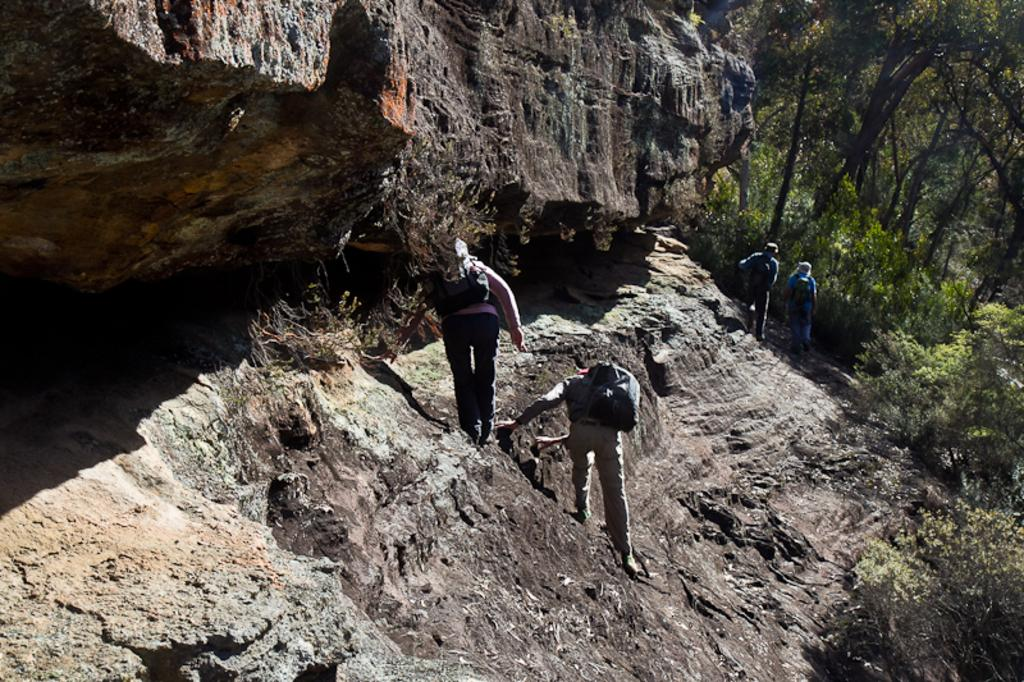How many people are walking in the image? There are four people walking in the image. What is the setting of the scene in the image? The scene appears to be on a hill. What type of vegetation can be seen in the image? There are trees with branches and leaves in the image. What type of governor is visible in the image? There is no governor present in the image. Can you tell me how many airplanes are flying in the image? There are no airplanes visible in the image. 